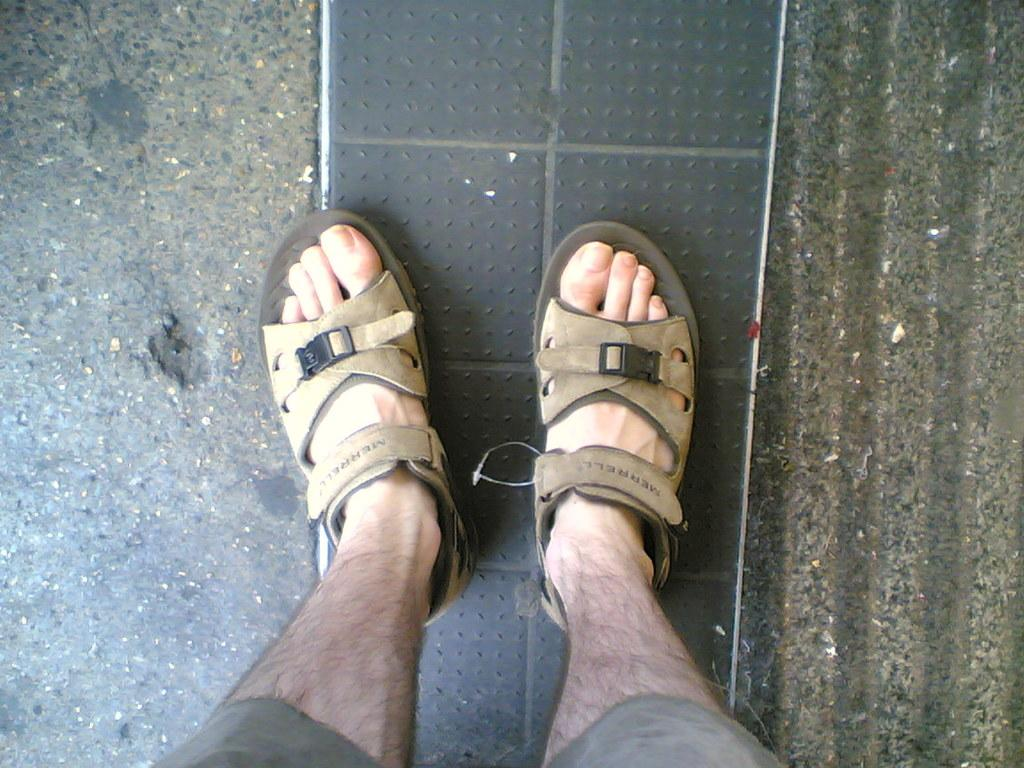What body parts are visible in the image? The image contains a person's legs. What surface is beneath the person's legs? There is a floor visible in the image. Are there any fairies visible around the person's legs in the image? No, there are no fairies present in the image. What type of ring can be seen on the person's finger in the image? There is no ring visible on the person's finger in the image. 